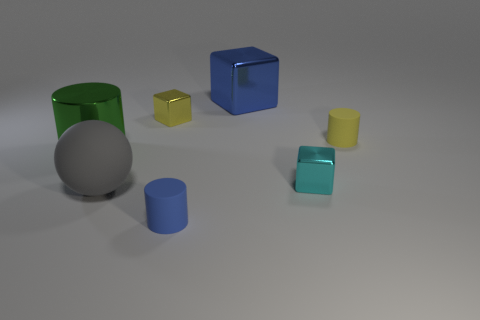The blue object that is behind the small cylinder behind the rubber object left of the blue rubber cylinder is made of what material?
Offer a very short reply. Metal. Does the green thing have the same size as the gray object?
Make the answer very short. Yes. There is a big metallic cylinder; is its color the same as the rubber thing that is to the right of the small blue rubber cylinder?
Give a very brief answer. No. There is a small yellow thing that is made of the same material as the green cylinder; what shape is it?
Give a very brief answer. Cube. There is a big metallic object that is behind the big green metallic cylinder; does it have the same shape as the large green object?
Ensure brevity in your answer.  No. There is a cube in front of the yellow shiny object behind the large gray object; what is its size?
Provide a succinct answer. Small. The other cylinder that is made of the same material as the yellow cylinder is what color?
Your answer should be compact. Blue. What number of shiny things are the same size as the sphere?
Offer a very short reply. 2. What number of red things are either big metallic cylinders or tiny metal things?
Offer a very short reply. 0. What number of objects are either large brown spheres or tiny cubes that are behind the yellow cylinder?
Offer a terse response. 1. 